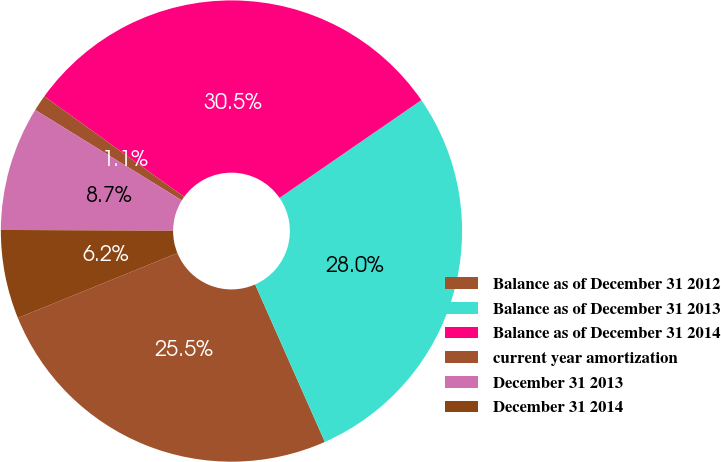<chart> <loc_0><loc_0><loc_500><loc_500><pie_chart><fcel>Balance as of December 31 2012<fcel>Balance as of December 31 2013<fcel>Balance as of December 31 2014<fcel>current year amortization<fcel>December 31 2013<fcel>December 31 2014<nl><fcel>25.48%<fcel>27.97%<fcel>30.46%<fcel>1.13%<fcel>8.72%<fcel>6.23%<nl></chart> 